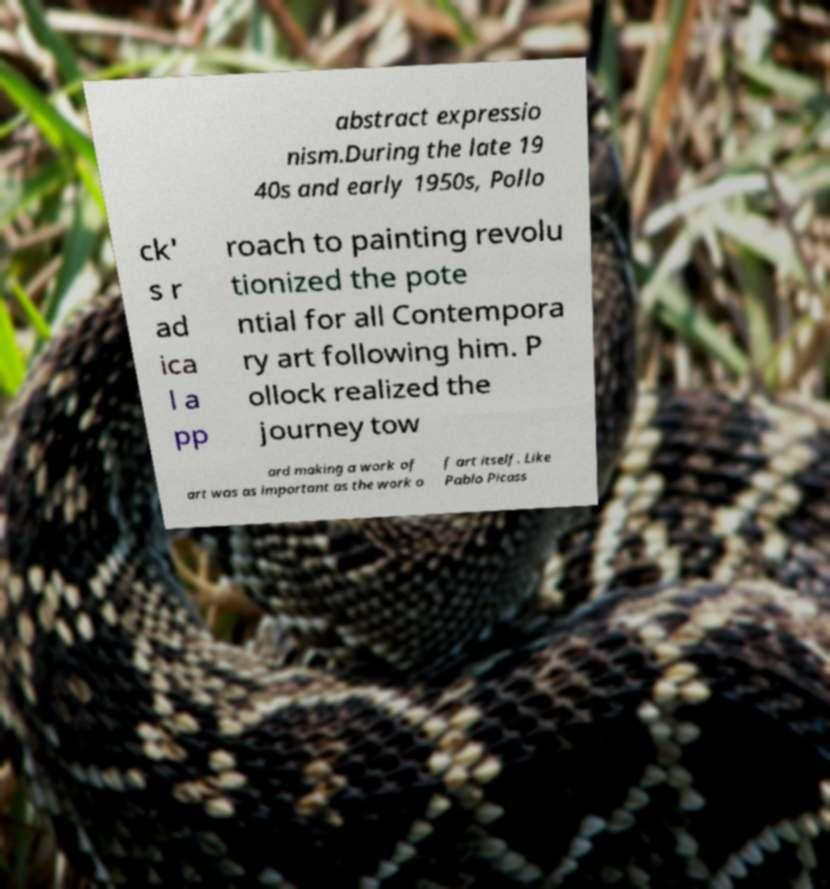There's text embedded in this image that I need extracted. Can you transcribe it verbatim? abstract expressio nism.During the late 19 40s and early 1950s, Pollo ck' s r ad ica l a pp roach to painting revolu tionized the pote ntial for all Contempora ry art following him. P ollock realized the journey tow ard making a work of art was as important as the work o f art itself. Like Pablo Picass 